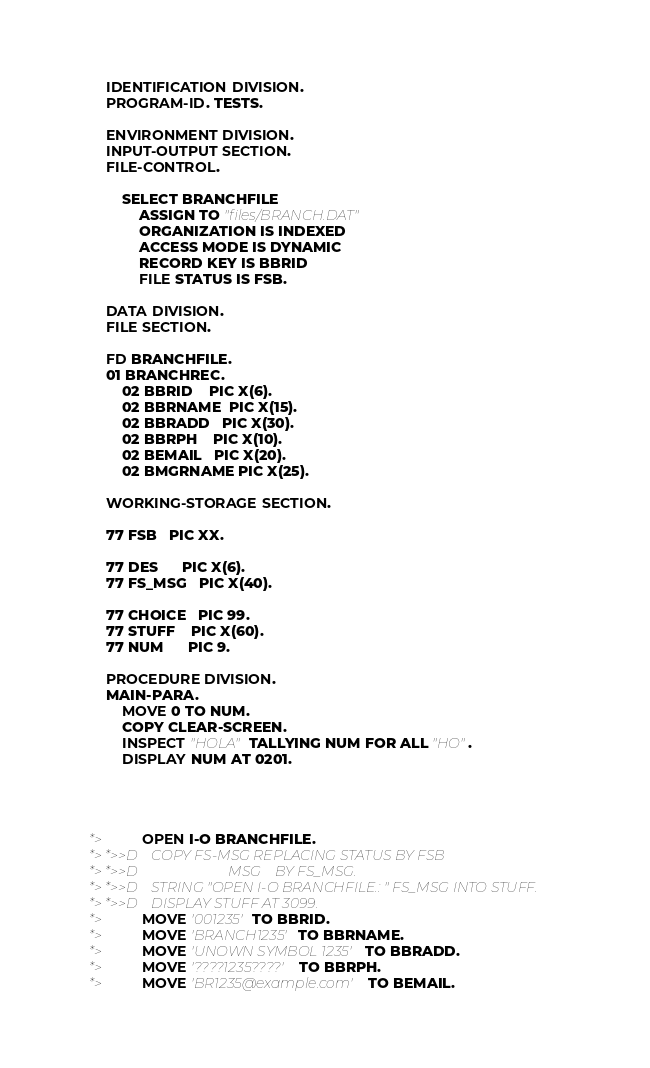<code> <loc_0><loc_0><loc_500><loc_500><_COBOL_>       IDENTIFICATION DIVISION.
       PROGRAM-ID. TESTS.

       ENVIRONMENT DIVISION.
       INPUT-OUTPUT SECTION.
       FILE-CONTROL.

           SELECT BRANCHFILE
               ASSIGN TO "files/BRANCH.DAT"
               ORGANIZATION IS INDEXED
               ACCESS MODE IS DYNAMIC
               RECORD KEY IS BBRID
               FILE STATUS IS FSB.

       DATA DIVISION.
       FILE SECTION.

       FD BRANCHFILE.
       01 BRANCHREC.
           02 BBRID    PIC X(6).
           02 BBRNAME  PIC X(15).
           02 BBRADD   PIC X(30).
           02 BBRPH    PIC X(10).
           02 BEMAIL   PIC X(20).
           02 BMGRNAME PIC X(25).

       WORKING-STORAGE SECTION.

       77 FSB   PIC XX.

       77 DES      PIC X(6).
       77 FS_MSG   PIC X(40).

       77 CHOICE   PIC 99.
       77 STUFF    PIC X(60).
       77 NUM      PIC 9.

       PROCEDURE DIVISION.
       MAIN-PARA.
           MOVE 0 TO NUM.
           COPY CLEAR-SCREEN.
           INSPECT "HOLA" TALLYING NUM FOR ALL "HO".
           DISPLAY NUM AT 0201.




   *>         OPEN I-O BRANCHFILE.
   *> *>>D    COPY FS-MSG REPLACING STATUS BY FSB
   *> *>>D                          MSG    BY FS_MSG.
   *> *>>D    STRING "OPEN I-O BRANCHFILE.: " FS_MSG INTO STUFF.
   *> *>>D    DISPLAY STUFF AT 3099.
   *>         MOVE '001235' TO BBRID.
   *>         MOVE 'BRANCH1235' TO BBRNAME.
   *>         MOVE 'UNOWN SYMBOL 1235' TO BBRADD.
   *>         MOVE '????1235????' TO BBRPH.
   *>         MOVE 'BR1235@example.com' TO BEMAIL.</code> 